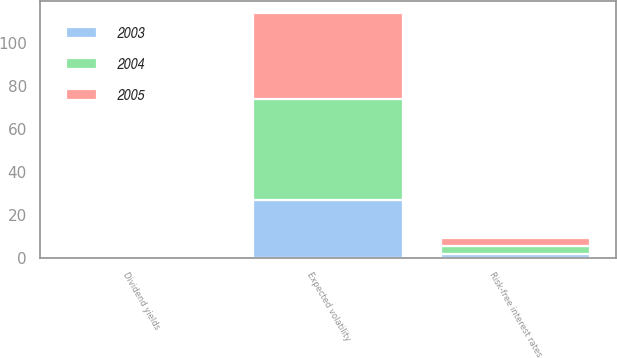Convert chart to OTSL. <chart><loc_0><loc_0><loc_500><loc_500><stacked_bar_chart><ecel><fcel>Risk-free interest rates<fcel>Expected volatility<fcel>Dividend yields<nl><fcel>2003<fcel>1.93<fcel>27.09<fcel>0.34<nl><fcel>2004<fcel>3.58<fcel>47<fcel>0.41<nl><fcel>2005<fcel>3.75<fcel>40<fcel>0.6<nl></chart> 